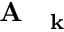<formula> <loc_0><loc_0><loc_500><loc_500>A _ { k }</formula> 